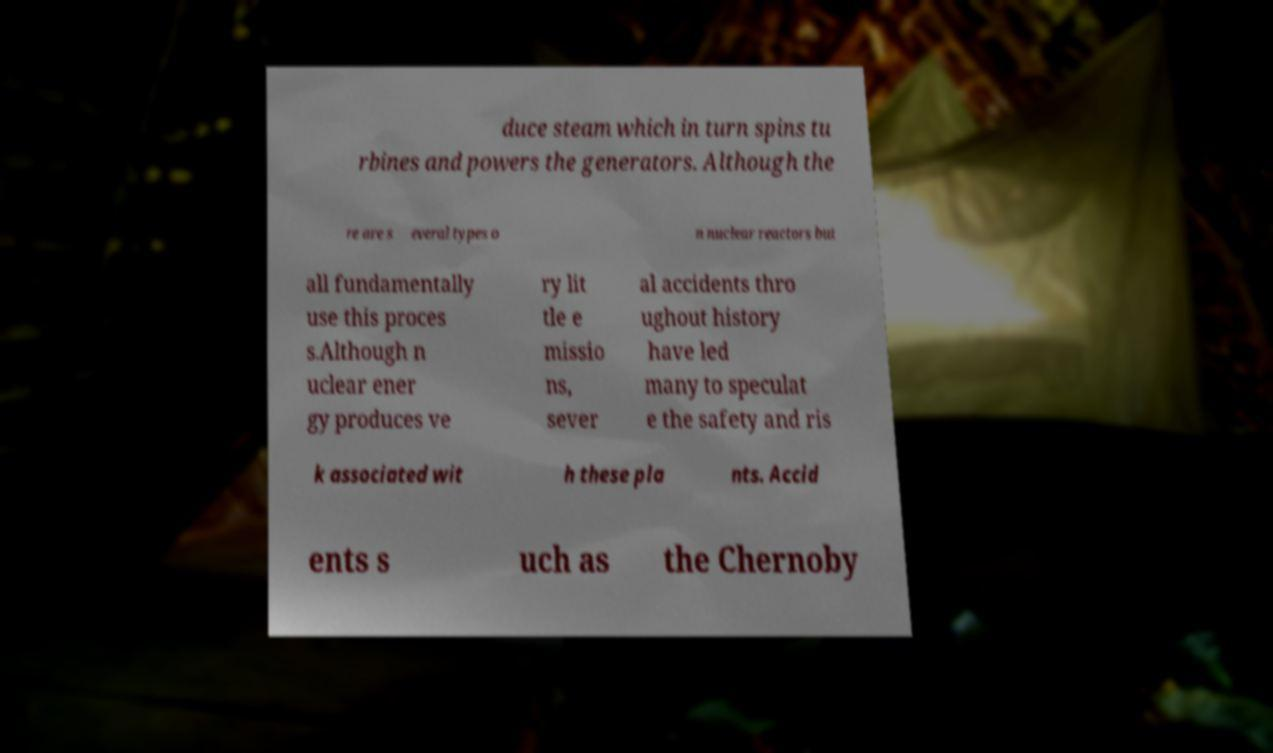I need the written content from this picture converted into text. Can you do that? duce steam which in turn spins tu rbines and powers the generators. Although the re are s everal types o n nuclear reactors but all fundamentally use this proces s.Although n uclear ener gy produces ve ry lit tle e missio ns, sever al accidents thro ughout history have led many to speculat e the safety and ris k associated wit h these pla nts. Accid ents s uch as the Chernoby 